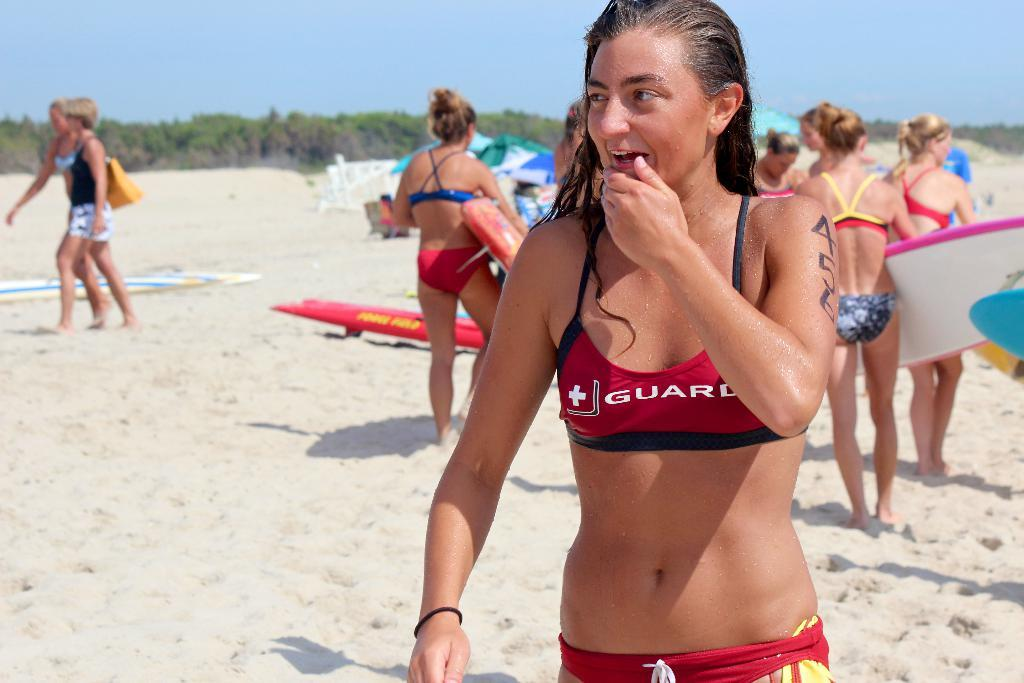Provide a one-sentence caption for the provided image. A girl in a bikini with brown hair in front on sand with people ,some holding surfboards behind her . 